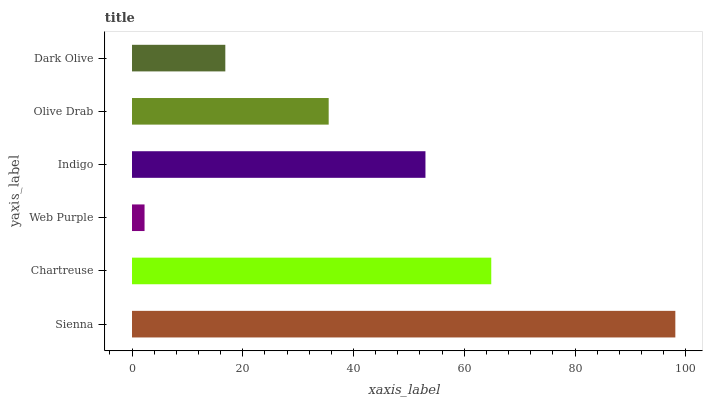Is Web Purple the minimum?
Answer yes or no. Yes. Is Sienna the maximum?
Answer yes or no. Yes. Is Chartreuse the minimum?
Answer yes or no. No. Is Chartreuse the maximum?
Answer yes or no. No. Is Sienna greater than Chartreuse?
Answer yes or no. Yes. Is Chartreuse less than Sienna?
Answer yes or no. Yes. Is Chartreuse greater than Sienna?
Answer yes or no. No. Is Sienna less than Chartreuse?
Answer yes or no. No. Is Indigo the high median?
Answer yes or no. Yes. Is Olive Drab the low median?
Answer yes or no. Yes. Is Sienna the high median?
Answer yes or no. No. Is Dark Olive the low median?
Answer yes or no. No. 